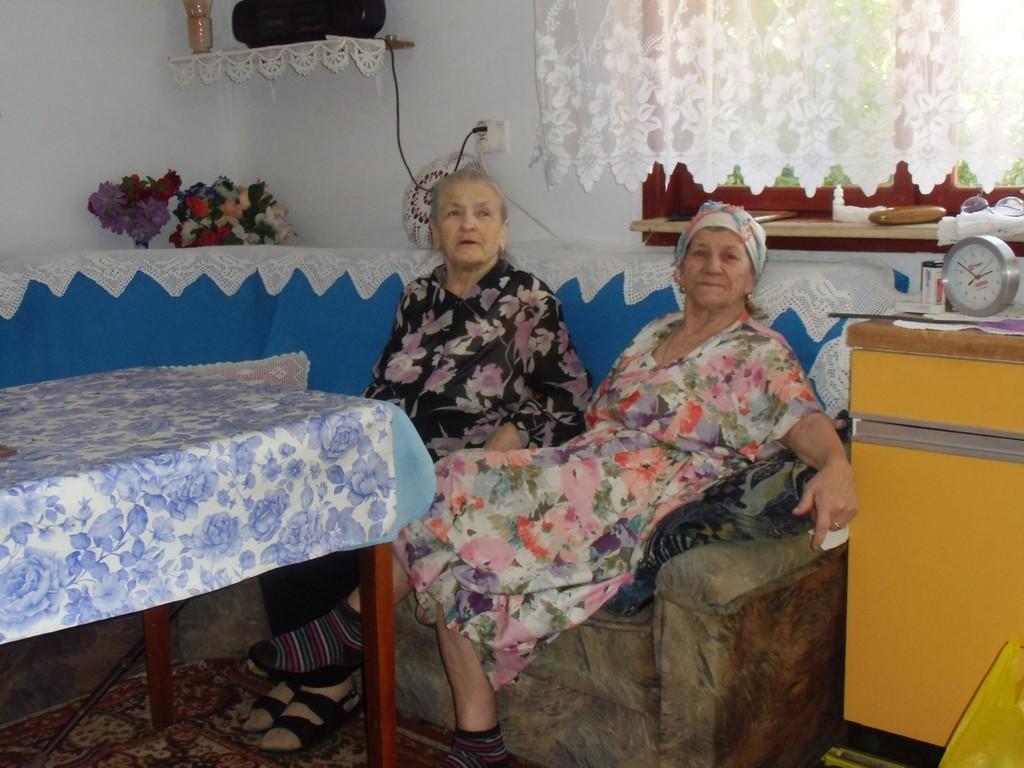How many people are in the image? There are two women in the image. What are the women doing in the image? The women are seated on a sofa. What other furniture is present in the image? There is a table in the image. What object can be used to tell time in the image? There is a clock in the image. What type of wax is being used by the spy in the image? There is no spy or wax present in the image; it features two women seated on a sofa. Can you describe the beetle that is crawling on the clock in the image? There is no beetle present on the clock or anywhere else in the image. 